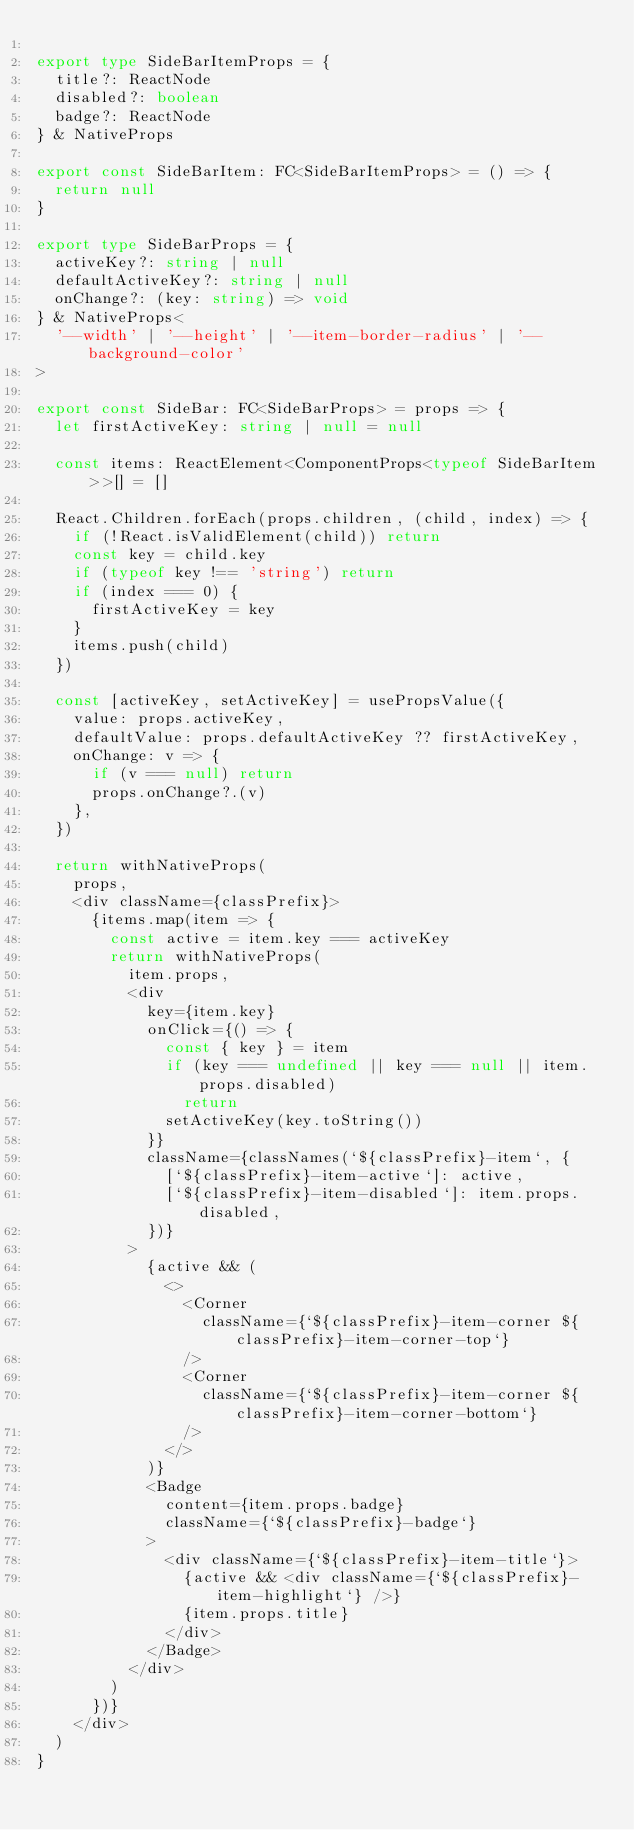Convert code to text. <code><loc_0><loc_0><loc_500><loc_500><_TypeScript_>
export type SideBarItemProps = {
  title?: ReactNode
  disabled?: boolean
  badge?: ReactNode
} & NativeProps

export const SideBarItem: FC<SideBarItemProps> = () => {
  return null
}

export type SideBarProps = {
  activeKey?: string | null
  defaultActiveKey?: string | null
  onChange?: (key: string) => void
} & NativeProps<
  '--width' | '--height' | '--item-border-radius' | '--background-color'
>

export const SideBar: FC<SideBarProps> = props => {
  let firstActiveKey: string | null = null

  const items: ReactElement<ComponentProps<typeof SideBarItem>>[] = []

  React.Children.forEach(props.children, (child, index) => {
    if (!React.isValidElement(child)) return
    const key = child.key
    if (typeof key !== 'string') return
    if (index === 0) {
      firstActiveKey = key
    }
    items.push(child)
  })

  const [activeKey, setActiveKey] = usePropsValue({
    value: props.activeKey,
    defaultValue: props.defaultActiveKey ?? firstActiveKey,
    onChange: v => {
      if (v === null) return
      props.onChange?.(v)
    },
  })

  return withNativeProps(
    props,
    <div className={classPrefix}>
      {items.map(item => {
        const active = item.key === activeKey
        return withNativeProps(
          item.props,
          <div
            key={item.key}
            onClick={() => {
              const { key } = item
              if (key === undefined || key === null || item.props.disabled)
                return
              setActiveKey(key.toString())
            }}
            className={classNames(`${classPrefix}-item`, {
              [`${classPrefix}-item-active`]: active,
              [`${classPrefix}-item-disabled`]: item.props.disabled,
            })}
          >
            {active && (
              <>
                <Corner
                  className={`${classPrefix}-item-corner ${classPrefix}-item-corner-top`}
                />
                <Corner
                  className={`${classPrefix}-item-corner ${classPrefix}-item-corner-bottom`}
                />
              </>
            )}
            <Badge
              content={item.props.badge}
              className={`${classPrefix}-badge`}
            >
              <div className={`${classPrefix}-item-title`}>
                {active && <div className={`${classPrefix}-item-highlight`} />}
                {item.props.title}
              </div>
            </Badge>
          </div>
        )
      })}
    </div>
  )
}
</code> 